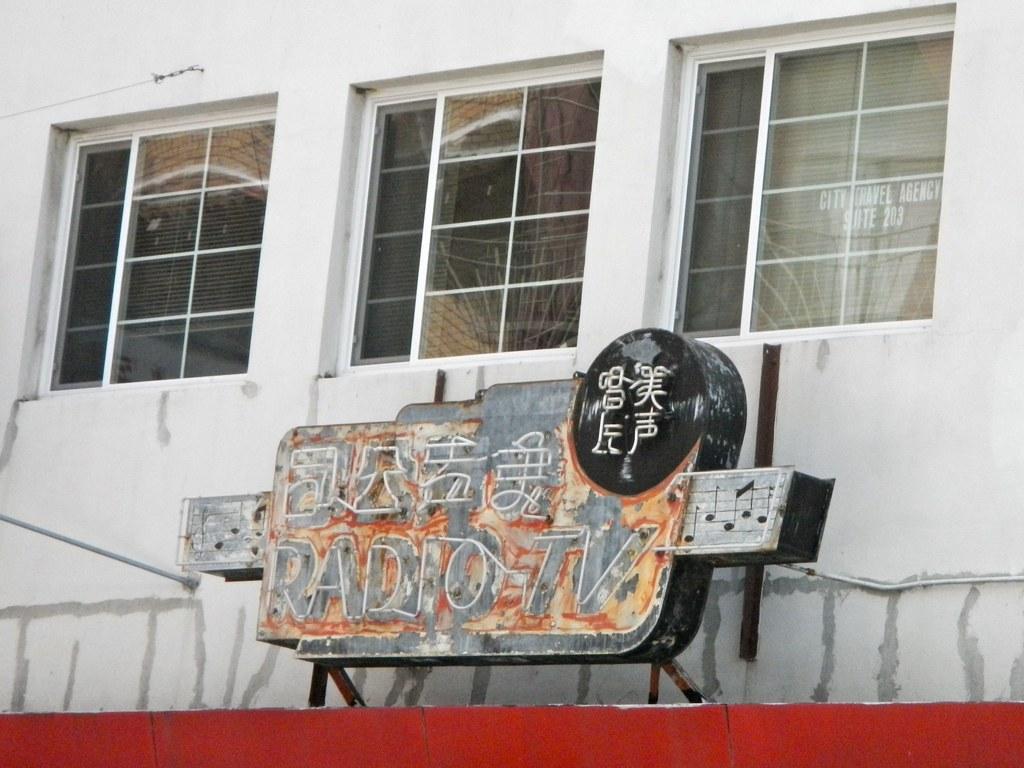Can you describe this image briefly? We can see board,wall and glass windows. 